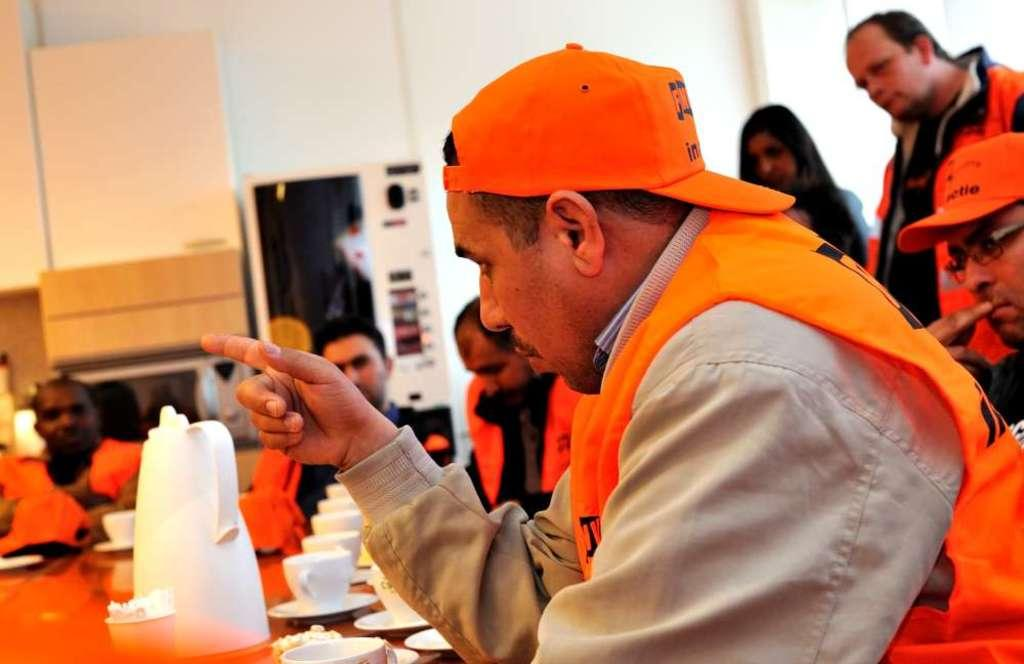Who or what can be seen in the image? There are people in the image. What is located on the left side of the image? There are objects on a table on the left side of the image. What can be seen in the background of the image? There is a wall visible in the background of the image. What type of quartz is present on the table in the image? There is no quartz present on the table in the image. What hall is visible in the background of the image? There is no hall visible in the background of the image; only a wall is present. 